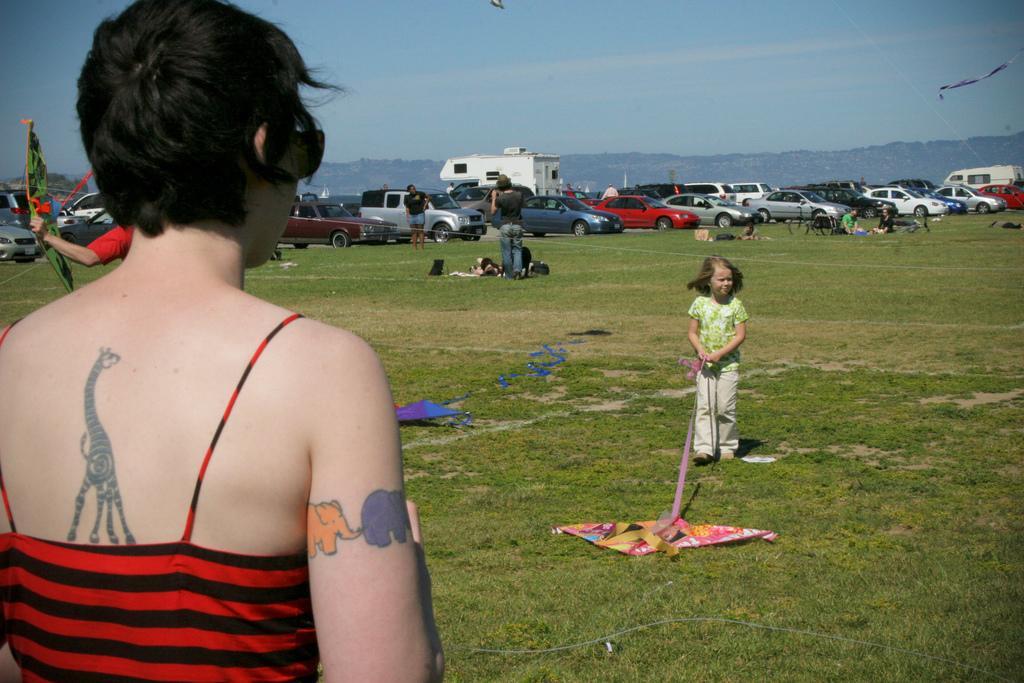Can you describe this image briefly? This image is clicked outside. There are cars in the middle. There is sky at the top. There are some people who are flying kites. There are some people in the middle, who are standing on grass. 